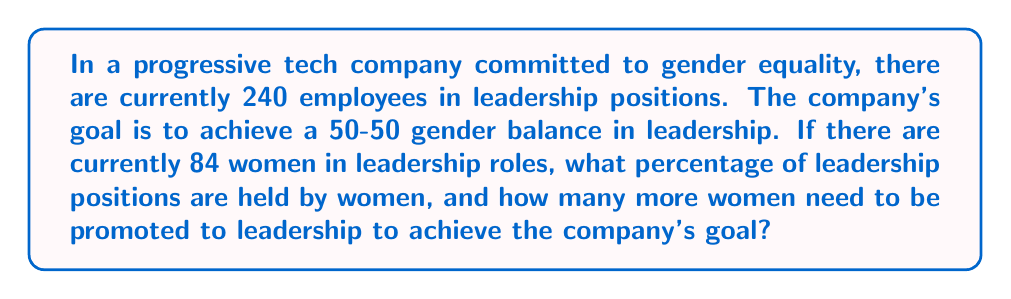Teach me how to tackle this problem. Let's approach this problem step by step:

1. Calculate the current percentage of women in leadership:
   - Total leadership positions: 240
   - Women in leadership: 84
   
   Percentage = $\frac{\text{Women in leadership}}{\text{Total leadership positions}} \times 100\%$
   
   $$\text{Percentage} = \frac{84}{240} \times 100\% = 35\%$$

2. Determine the number of women needed for 50-50 balance:
   - 50% of 240 = $240 \times 0.5 = 120$ women

3. Calculate how many more women need to be promoted:
   - Women needed - Current women in leadership
   $$120 - 84 = 36$$

Thus, 36 more women need to be promoted to leadership positions to achieve the 50-50 gender balance goal.
Answer: Currently, women hold 35% of leadership positions. To achieve the company's 50-50 gender balance goal, 36 more women need to be promoted to leadership roles. 